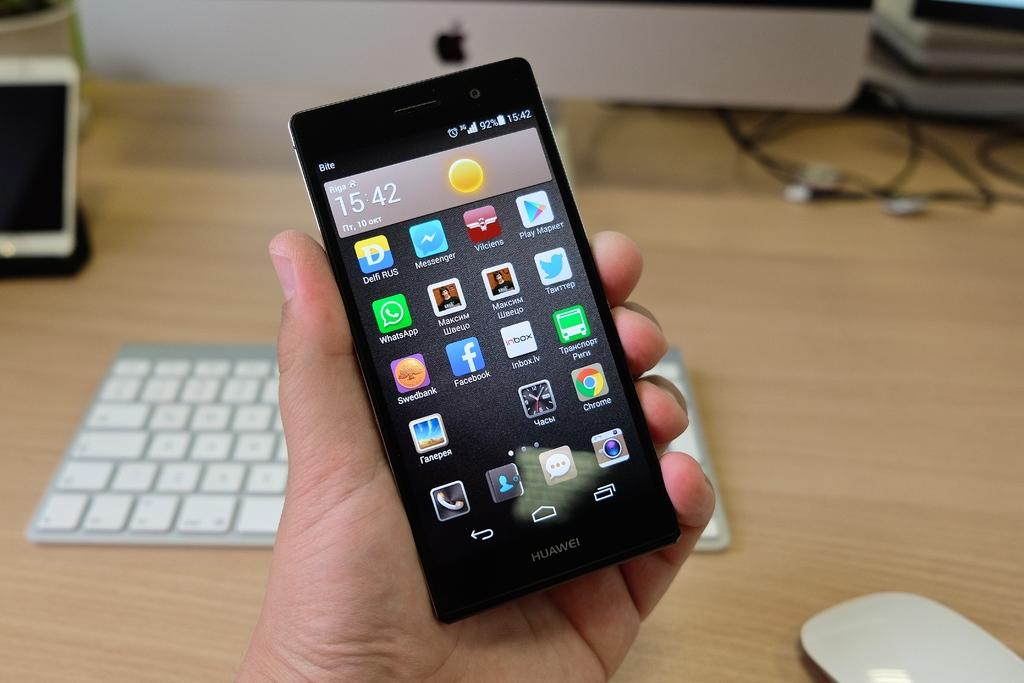<image>
Render a clear and concise summary of the photo. a black Huawei cell phone with the time at 15:42 